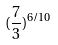<formula> <loc_0><loc_0><loc_500><loc_500>( \frac { 7 } { 3 } ) ^ { 6 / 1 0 }</formula> 